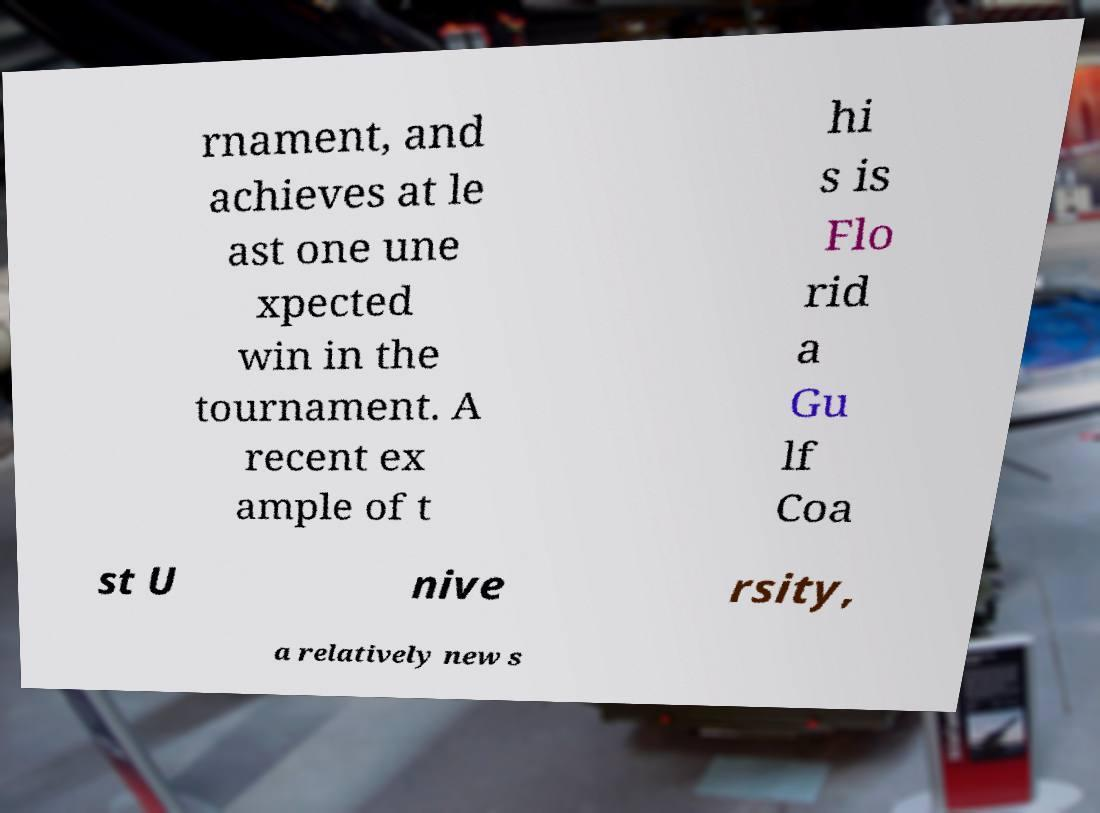Can you read and provide the text displayed in the image?This photo seems to have some interesting text. Can you extract and type it out for me? rnament, and achieves at le ast one une xpected win in the tournament. A recent ex ample of t hi s is Flo rid a Gu lf Coa st U nive rsity, a relatively new s 